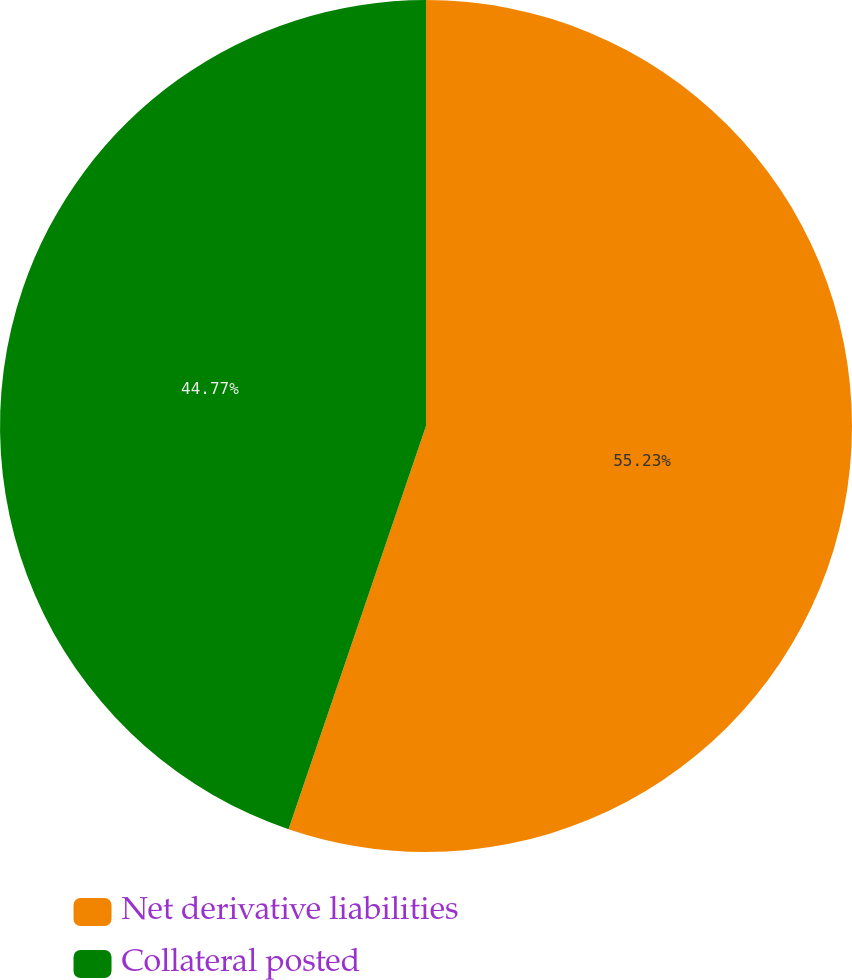<chart> <loc_0><loc_0><loc_500><loc_500><pie_chart><fcel>Net derivative liabilities<fcel>Collateral posted<nl><fcel>55.23%<fcel>44.77%<nl></chart> 